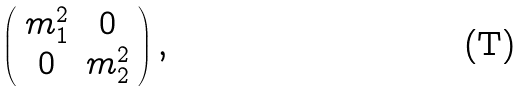<formula> <loc_0><loc_0><loc_500><loc_500>\left ( \begin{array} { c c } m ^ { 2 } _ { 1 } & 0 \\ 0 & m ^ { 2 } _ { 2 } \end{array} \right ) ,</formula> 